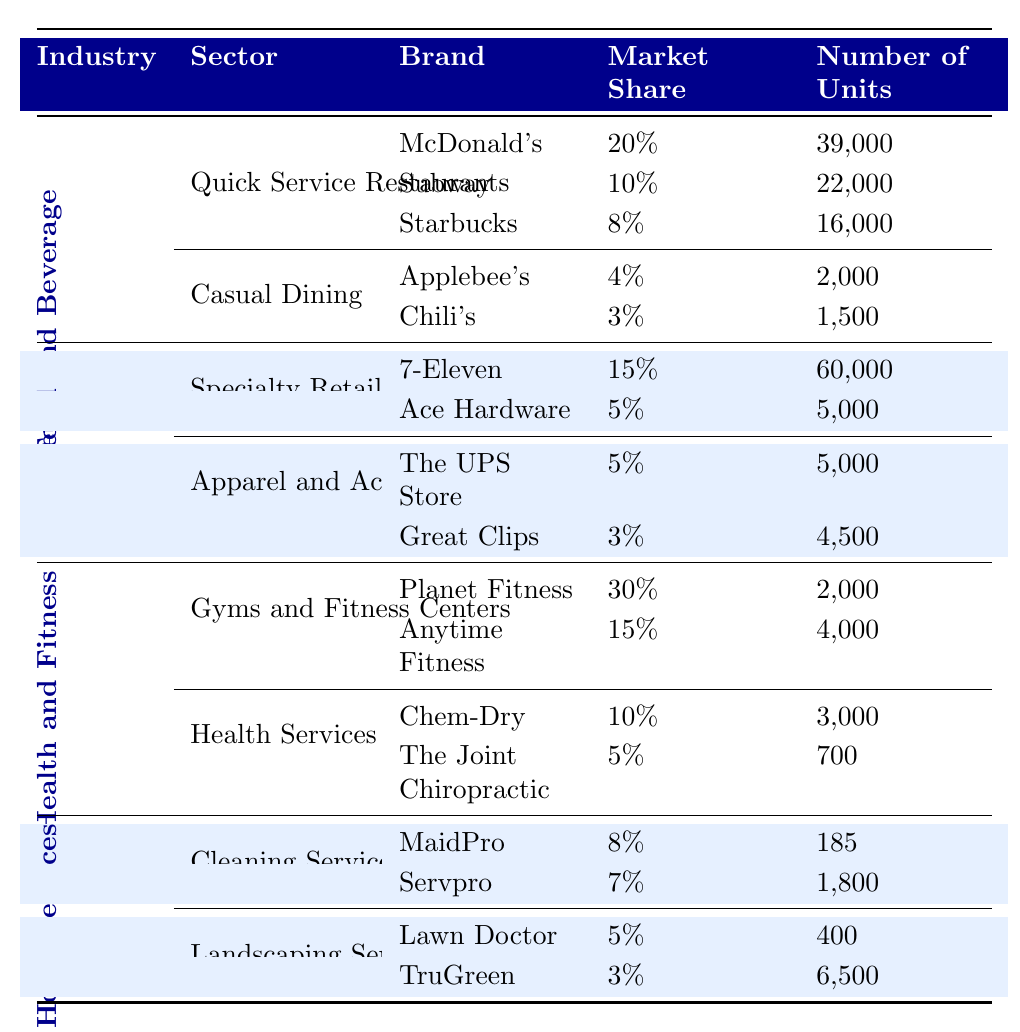What is the market share of Starbucks? According to the table, Starbucks has a market share of 8% within the Quick Service Restaurants sector of the Food and Beverage industry.
Answer: 8% Which brand has the largest number of units in the Specialty Retail sector? The table shows that 7-Eleven has the largest number of units with 60,000 units, compared to 5,000 units for Ace Hardware.
Answer: 7-Eleven What is the total market share percentage of the top brands in Casual Dining? To find the total market share in Casual Dining, we sum the individual market shares: 4% (Applebee's) + 3% (Chili's) = 7%.
Answer: 7% Is the market share of Anytime Fitness greater than that of Chem-Dry? Anytime Fitness has a market share of 15%, while Chem-Dry has a market share of 10%. Since 15% is greater than 10%, the statement is true.
Answer: Yes What is the average number of units for the top brands in Health Services? The number of units for the top brands in Health Services are 3,000 (Chem-Dry) and 700 (The Joint Chiropractic). The average is (3000 + 700) / 2 = 3,700 / 2 = 1,850.
Answer: 1,850 Which sector has the most brands listed in the table? The Food and Beverage industry has two sectors listed (Quick Service Restaurants and Casual Dining), whereas the Retail, Health and Fitness, and Home Services industries have two or fewer sectors. Therefore, Food and Beverage has the most brands listed.
Answer: Food and Beverage What is the difference in the number of units between McDonald's and Subway? McDonald's has 39,000 units, and Subway has 22,000 units. The difference is 39,000 - 22,000 = 17,000 units.
Answer: 17,000 Are there more total units in Landscaping Services than in Gyms and Fitness Centers? In Landscaping Services, the total units are 400 (Lawn Doctor) + 6,500 (TruGreen) = 6,900 units. In Gyms and Fitness Centers, the total units are 2,000 (Planet Fitness) + 4,000 (Anytime Fitness) = 6,000 units. Therefore, 6,900 is greater than 6,000; the statement is true.
Answer: Yes 